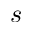Convert formula to latex. <formula><loc_0><loc_0><loc_500><loc_500>s</formula> 